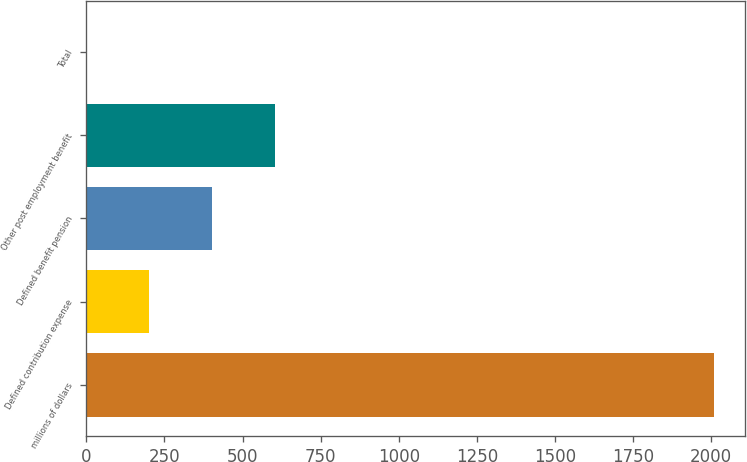Convert chart to OTSL. <chart><loc_0><loc_0><loc_500><loc_500><bar_chart><fcel>millions of dollars<fcel>Defined contribution expense<fcel>Defined benefit pension<fcel>Other post employment benefit<fcel>Total<nl><fcel>2009<fcel>202.07<fcel>402.84<fcel>603.61<fcel>1.3<nl></chart> 